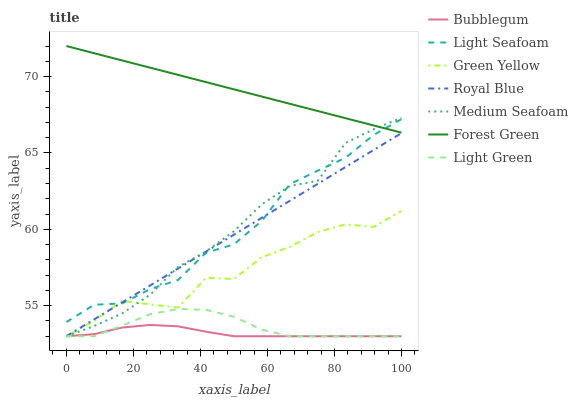Does Bubblegum have the minimum area under the curve?
Answer yes or no. Yes. Does Forest Green have the maximum area under the curve?
Answer yes or no. Yes. Does Royal Blue have the minimum area under the curve?
Answer yes or no. No. Does Royal Blue have the maximum area under the curve?
Answer yes or no. No. Is Royal Blue the smoothest?
Answer yes or no. Yes. Is Green Yellow the roughest?
Answer yes or no. Yes. Is Bubblegum the smoothest?
Answer yes or no. No. Is Bubblegum the roughest?
Answer yes or no. No. Does Bubblegum have the lowest value?
Answer yes or no. Yes. Does Forest Green have the lowest value?
Answer yes or no. No. Does Forest Green have the highest value?
Answer yes or no. Yes. Does Royal Blue have the highest value?
Answer yes or no. No. Is Royal Blue less than Forest Green?
Answer yes or no. Yes. Is Forest Green greater than Royal Blue?
Answer yes or no. Yes. Does Light Green intersect Royal Blue?
Answer yes or no. Yes. Is Light Green less than Royal Blue?
Answer yes or no. No. Is Light Green greater than Royal Blue?
Answer yes or no. No. Does Royal Blue intersect Forest Green?
Answer yes or no. No. 